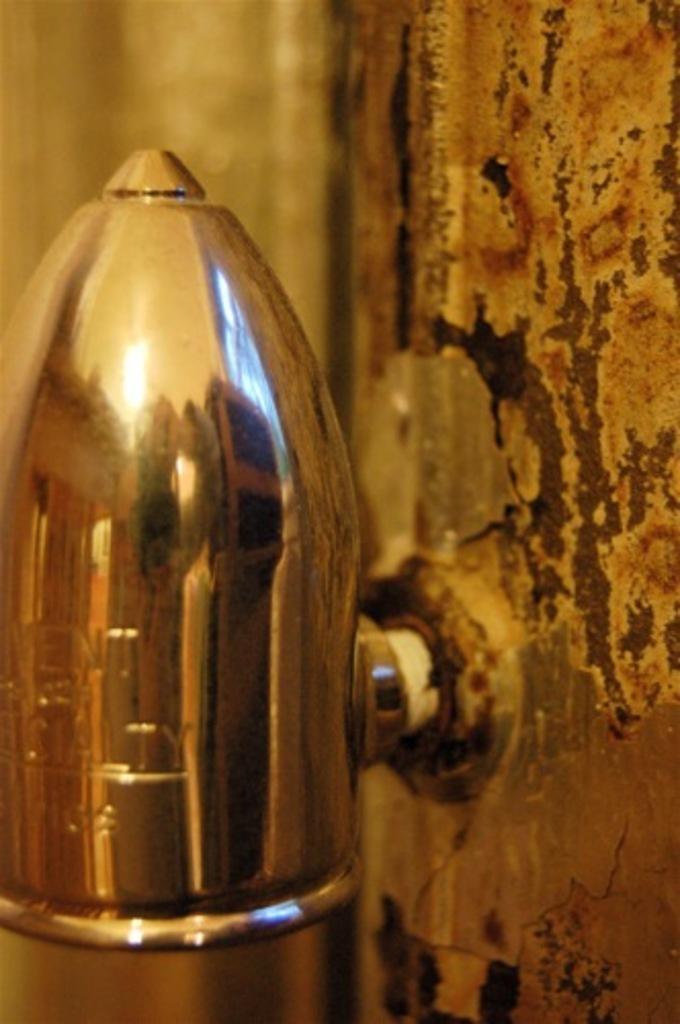Please provide a concise description of this image. In the picture there is some object fit to the wall. 